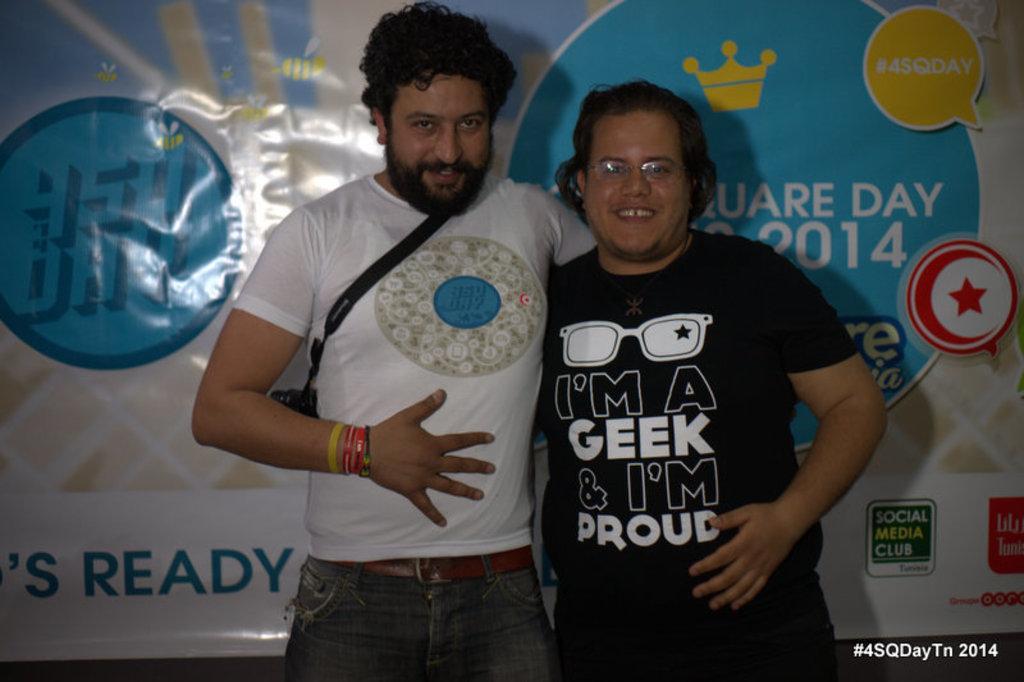Please provide a concise description of this image. In the middle of this image, there are two persons smiling and standing. On the bottom right, there is a watermark. In the background, there is a banner. 